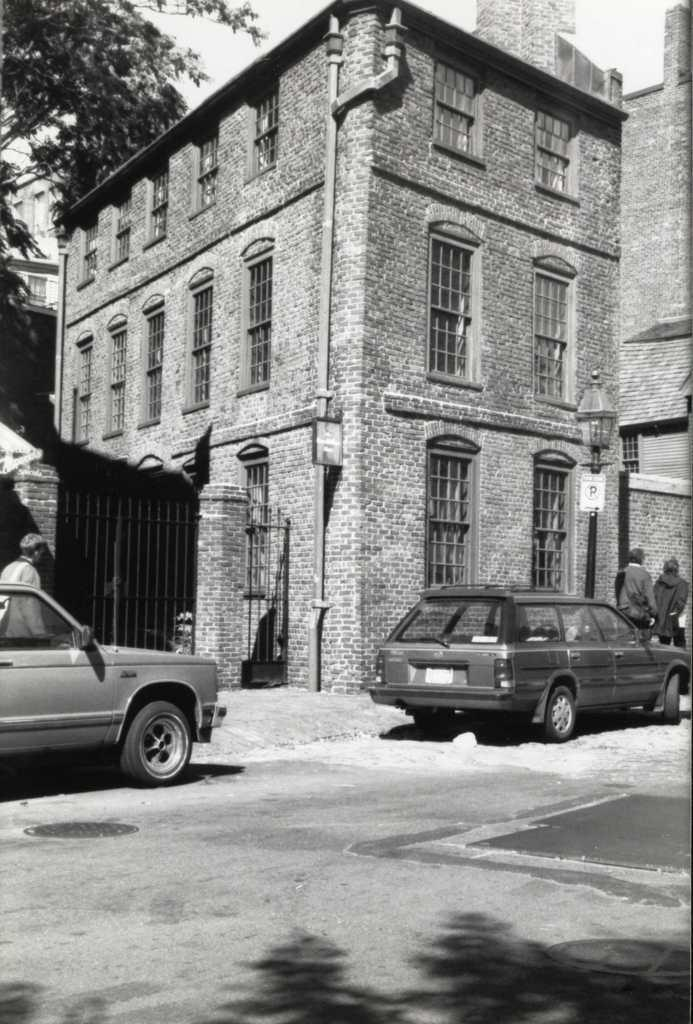What can be seen in the center of the image? There are two cars in the center of the image. Are there any people present in the image? Yes, there are people in the image. What can be seen in the background of the image? There are buildings and a tree in the background of the image. What is at the bottom of the image? There is a walkway at the bottom of the image. What type of reward can be seen hanging from the tree in the image? There is no reward hanging from the tree in the image; it is a tree in the background of the image. 